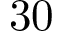<formula> <loc_0><loc_0><loc_500><loc_500>3 0</formula> 